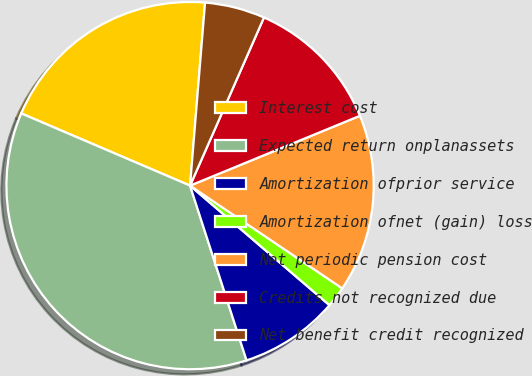Convert chart to OTSL. <chart><loc_0><loc_0><loc_500><loc_500><pie_chart><fcel>Interest cost<fcel>Expected return onplanassets<fcel>Amortization ofprior service<fcel>Amortization ofnet (gain) loss<fcel>Net periodic pension cost<fcel>Credits not recognized due<fcel>Net benefit credit recognized<nl><fcel>19.87%<fcel>36.41%<fcel>8.74%<fcel>1.83%<fcel>15.66%<fcel>12.2%<fcel>5.29%<nl></chart> 